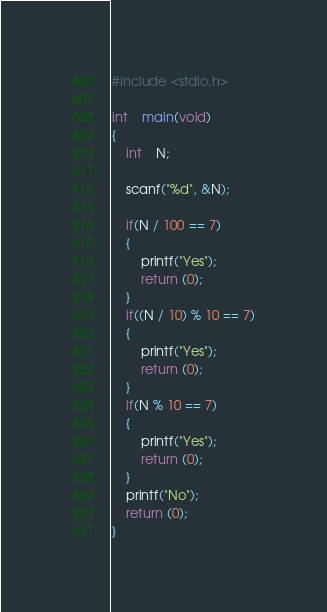Convert code to text. <code><loc_0><loc_0><loc_500><loc_500><_C_>#include <stdio.h>

int	main(void)
{
  	int	N;
  	
  	scanf("%d", &N);
  
  	if(N / 100 == 7)
    {
      	printf("Yes");
      	return (0);
    }
  	if((N / 10) % 10 == 7)
    {
      	printf("Yes");
      	return (0);
    }
  	if(N % 10 == 7)
    {
      	printf("Yes");
      	return (0);
    }
    printf("No");
    return (0);
}</code> 